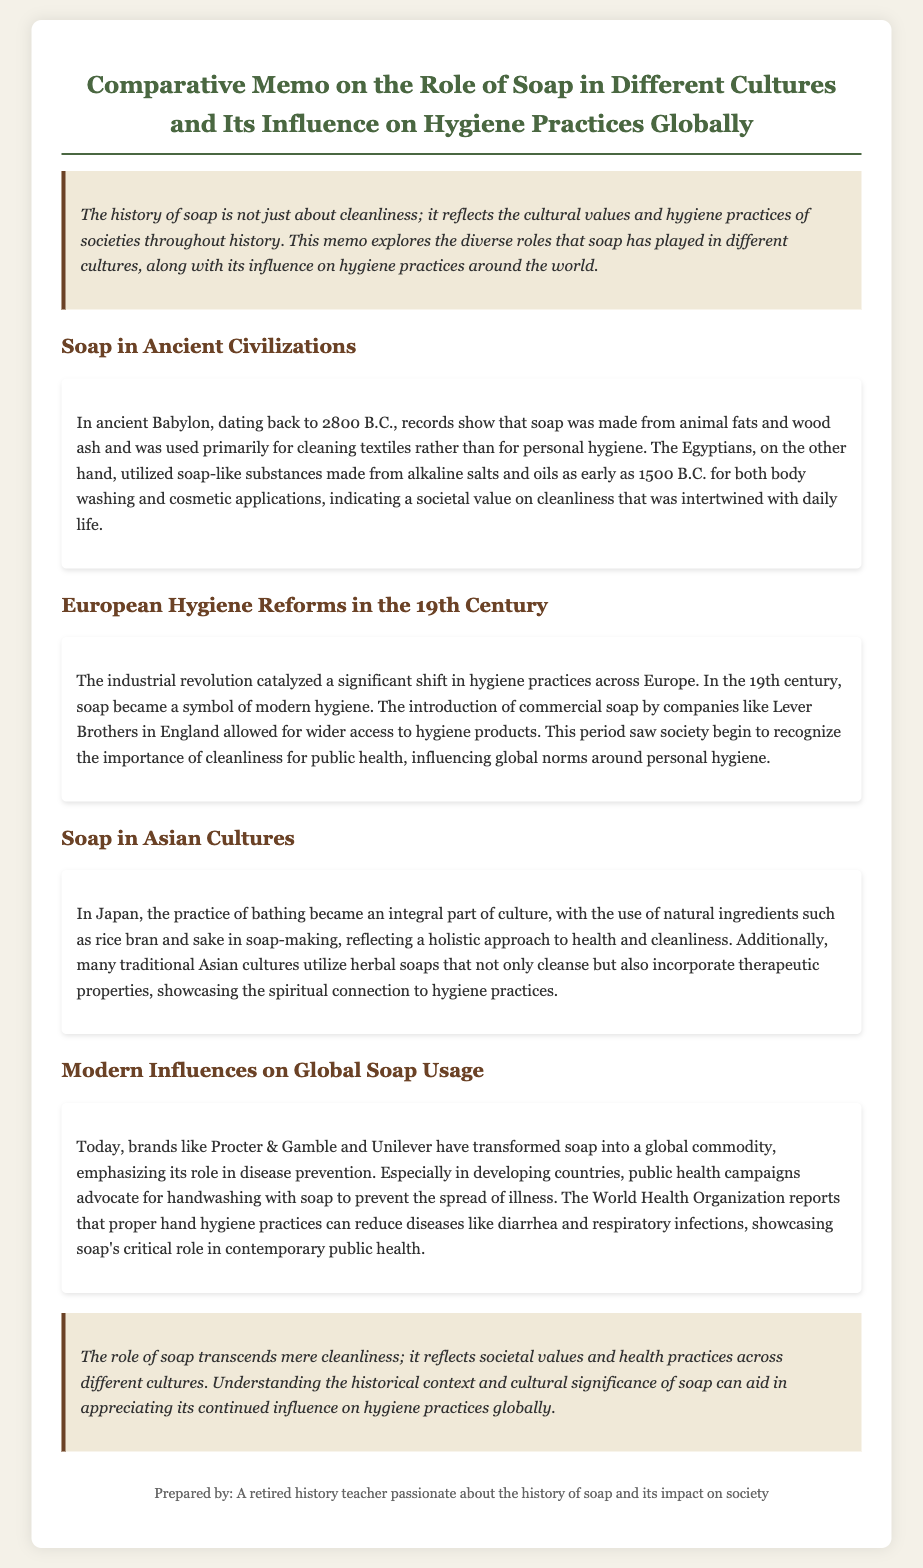What civilization used soap primarily for cleaning textiles? The document states that soap was made in ancient Babylon, primarily for cleaning textiles rather than for personal hygiene.
Answer: Babylon When did the Egyptians begin using soap-like substances? It is noted in the document that the Egyptians utilized soap-like substances as early as 1500 B.C.
Answer: 1500 B.C Which companies popularized commercial soap in 19th-century Europe? The memo mentions Lever Brothers in England as one of the companies that introduced commercial soap, leading to wider access to hygiene products.
Answer: Lever Brothers What natural ingredients are used in Japanese soap-making? The document explains that Japan used natural ingredients such as rice bran and sake in soap-making.
Answer: Rice bran and sake How has soap's role changed in modern public health? The document illustrates that public health campaigns advocate for handwashing with soap to prevent illness, indicating a shift in its role.
Answer: Disease prevention 